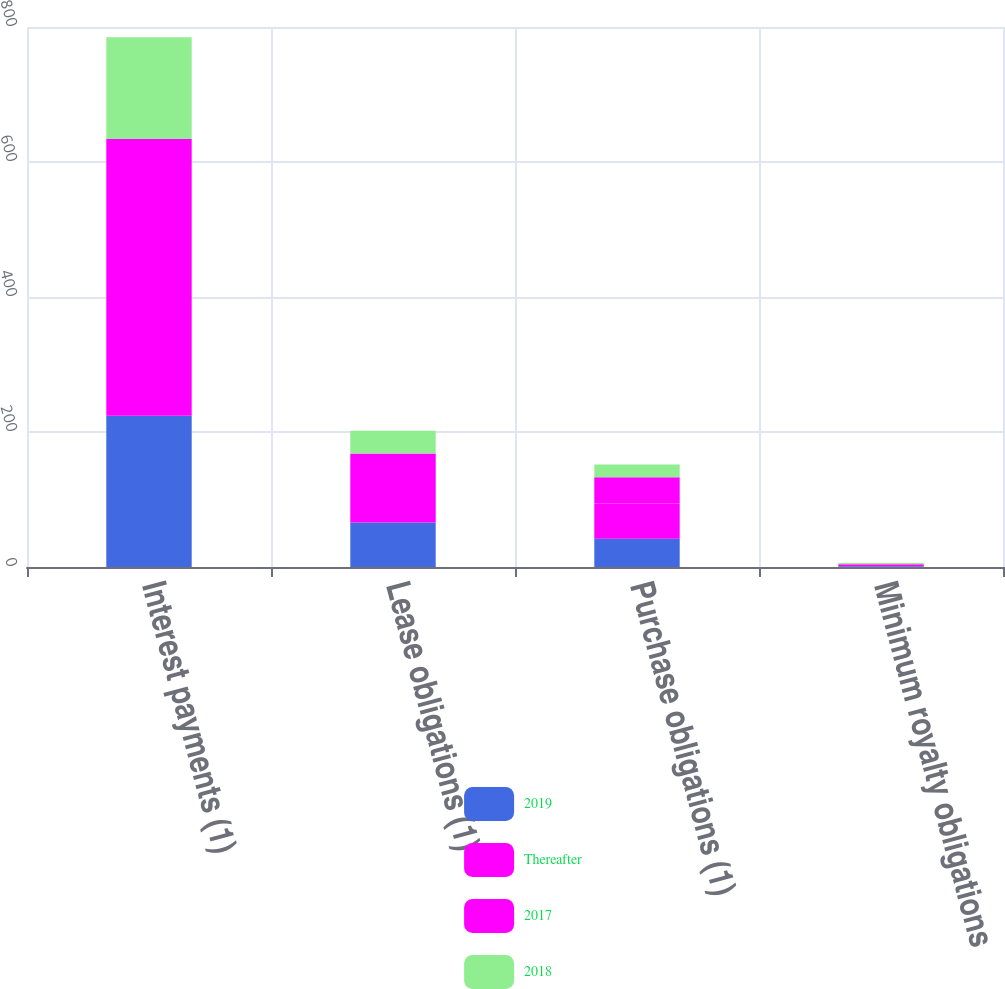Convert chart. <chart><loc_0><loc_0><loc_500><loc_500><stacked_bar_chart><ecel><fcel>Interest payments (1)<fcel>Lease obligations (1)<fcel>Purchase obligations (1)<fcel>Minimum royalty obligations<nl><fcel>2019<fcel>224<fcel>66<fcel>42<fcel>1<nl><fcel>Thereafter<fcel>216<fcel>60<fcel>52<fcel>2<nl><fcel>2017<fcel>194<fcel>42<fcel>39<fcel>1<nl><fcel>2018<fcel>151<fcel>34<fcel>19<fcel>2<nl></chart> 